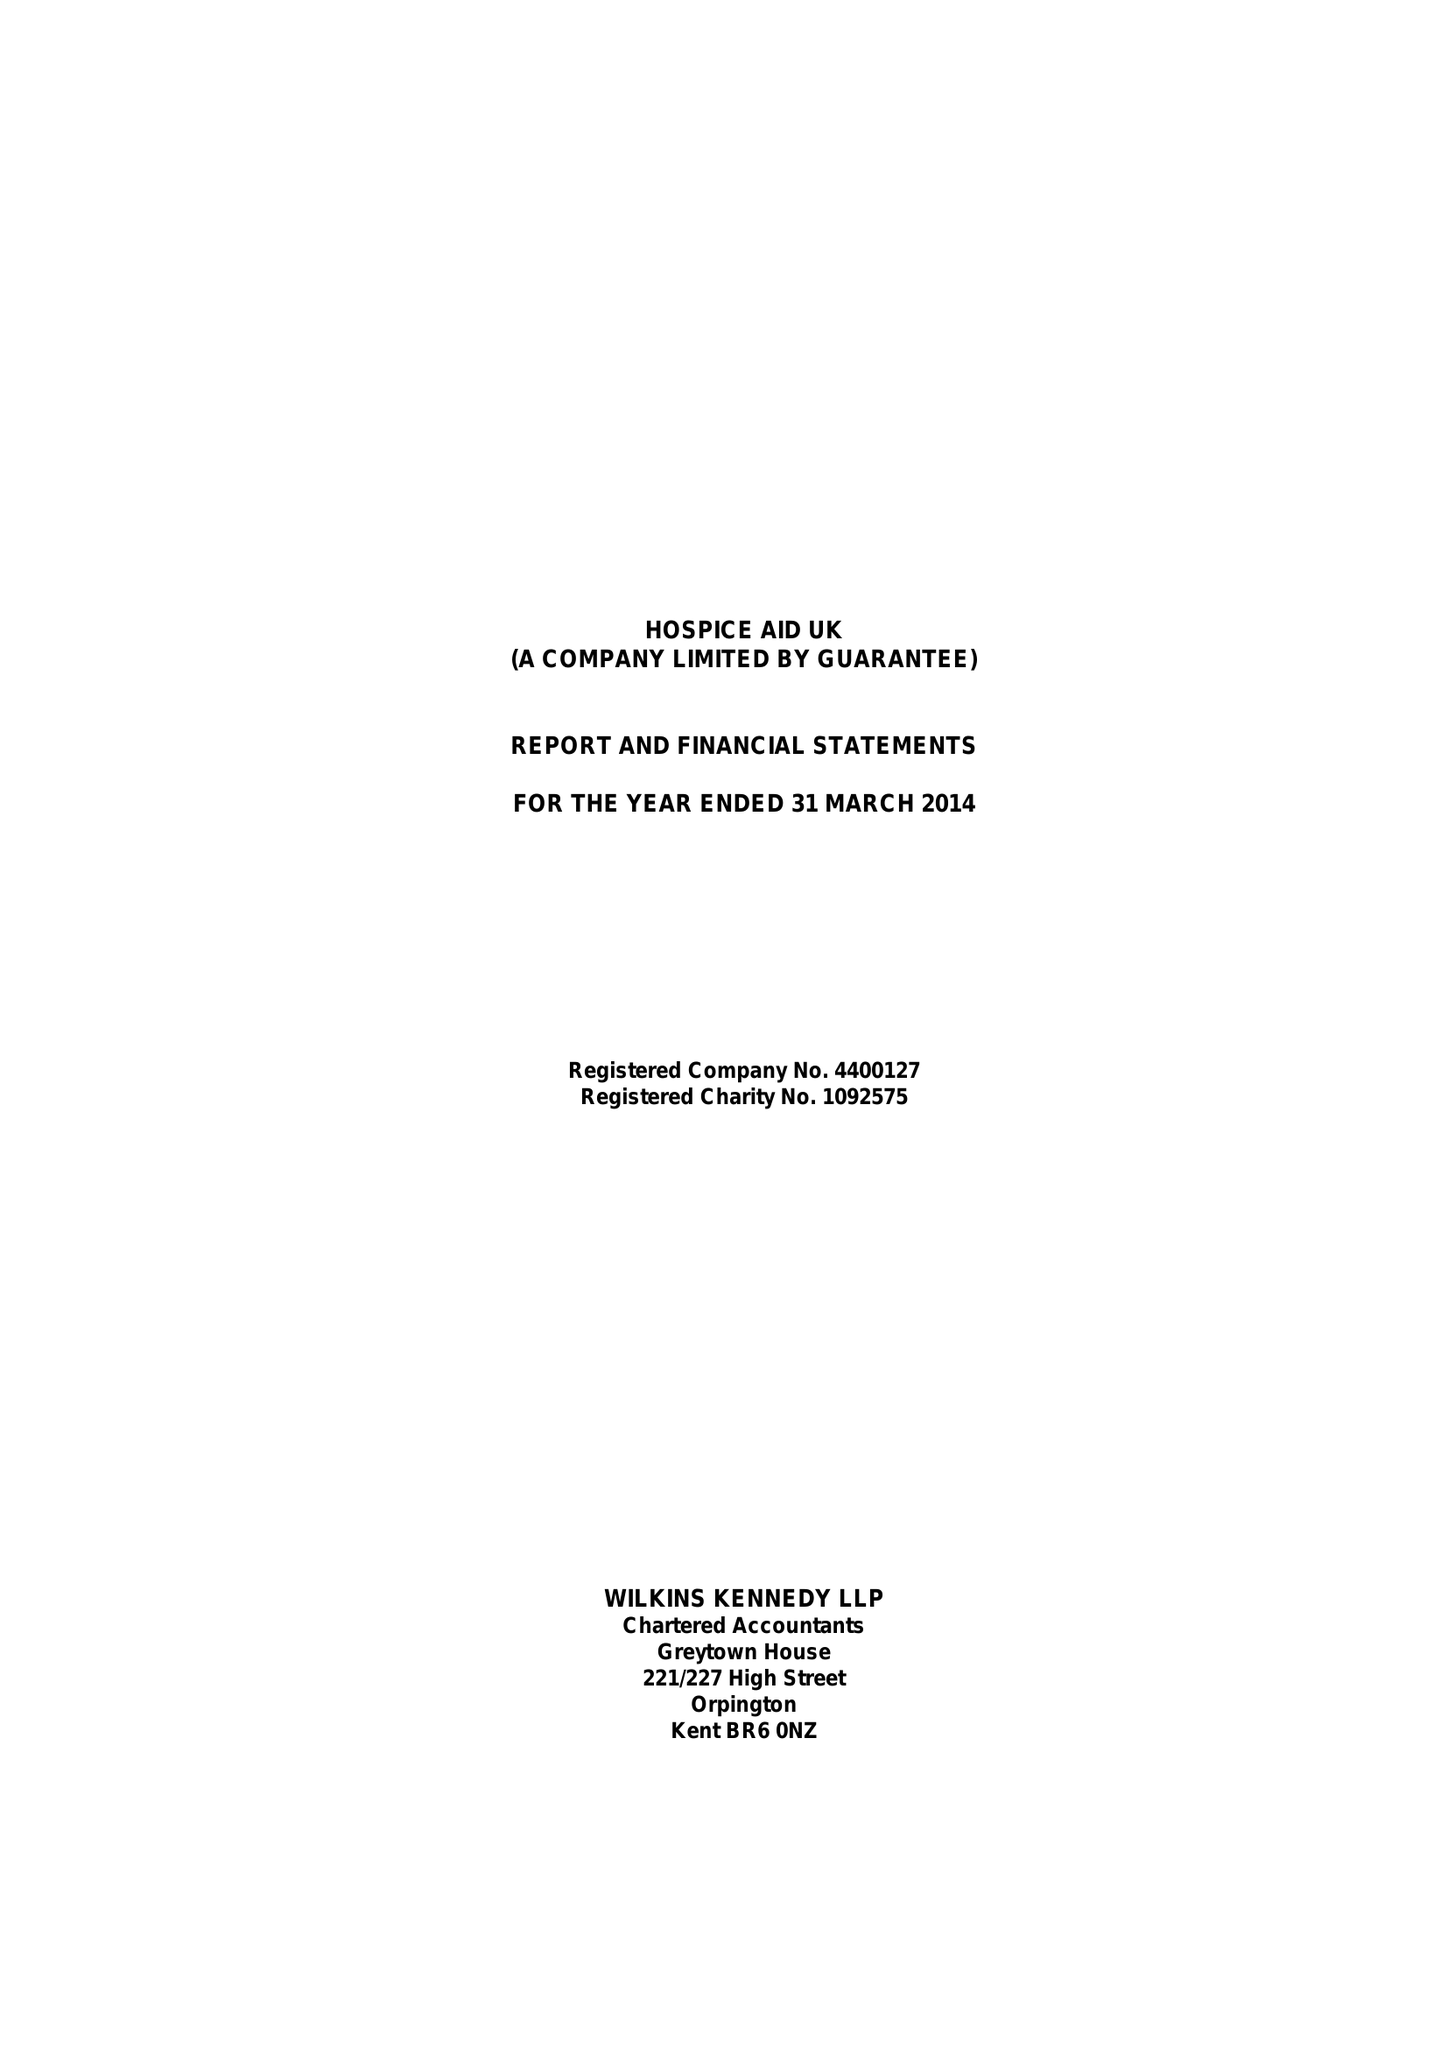What is the value for the income_annually_in_british_pounds?
Answer the question using a single word or phrase. 537211.00 